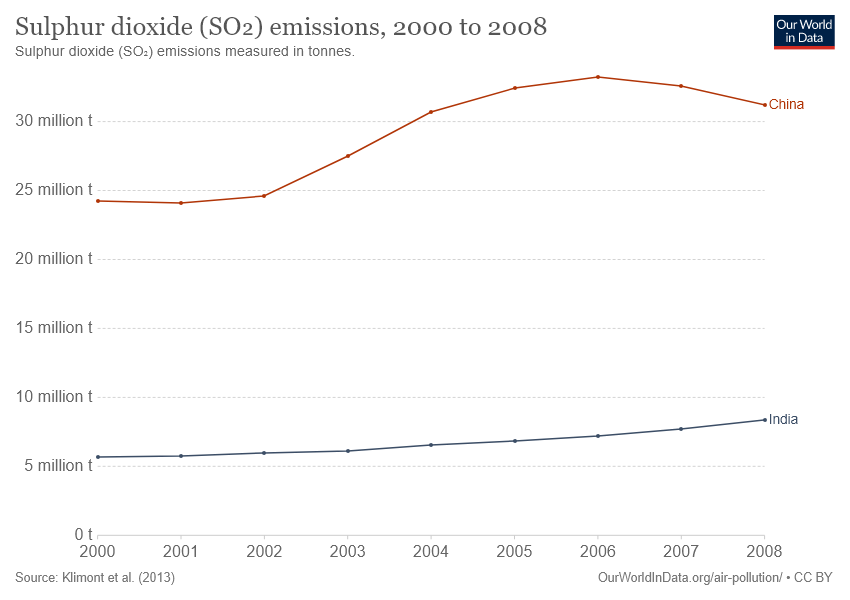Give some essential details in this illustration. In 2006, the Sulfur dioxide emissions from China were at their highest level. The given graph compares two countries, China and India, in terms of their population and GDP. 